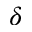Convert formula to latex. <formula><loc_0><loc_0><loc_500><loc_500>\delta</formula> 